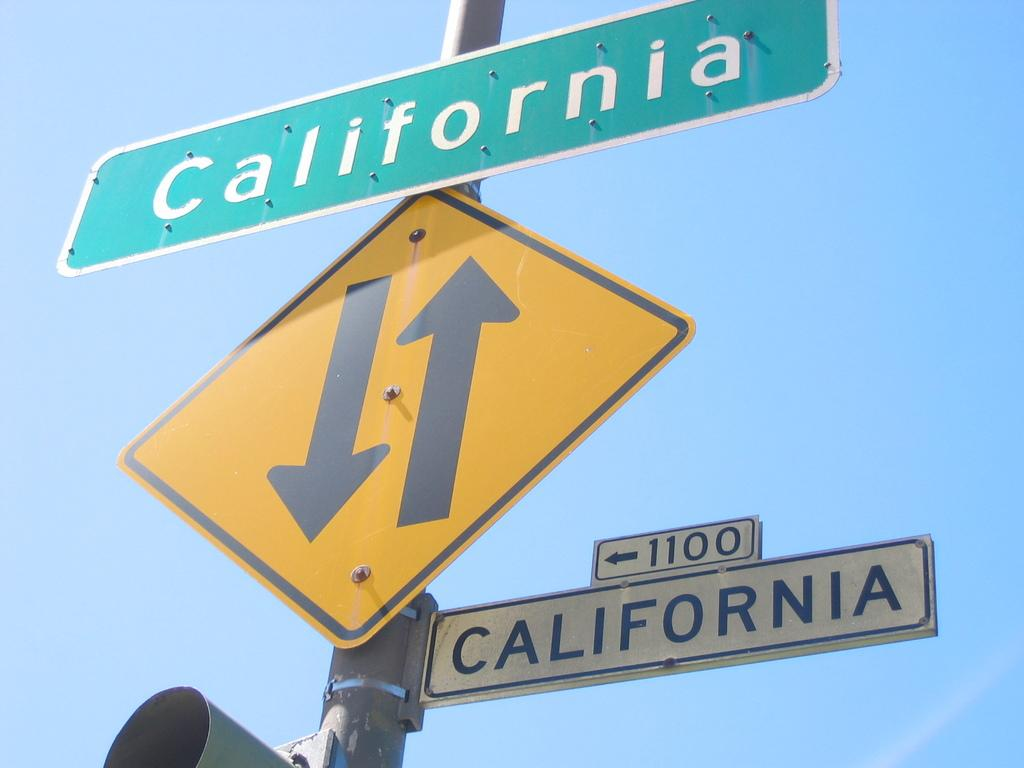Provide a one-sentence caption for the provided image. Street name signs in white and green both shows California as the name. 